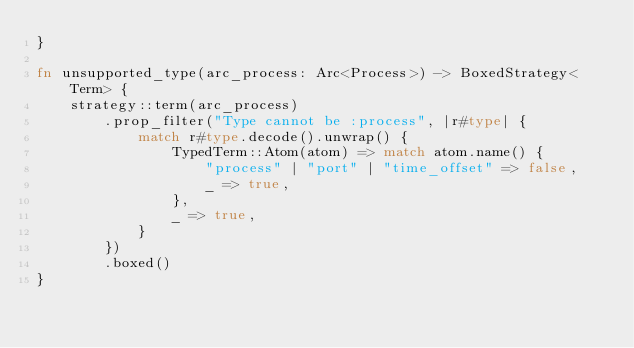Convert code to text. <code><loc_0><loc_0><loc_500><loc_500><_Rust_>}

fn unsupported_type(arc_process: Arc<Process>) -> BoxedStrategy<Term> {
    strategy::term(arc_process)
        .prop_filter("Type cannot be :process", |r#type| {
            match r#type.decode().unwrap() {
                TypedTerm::Atom(atom) => match atom.name() {
                    "process" | "port" | "time_offset" => false,
                    _ => true,
                },
                _ => true,
            }
        })
        .boxed()
}
</code> 